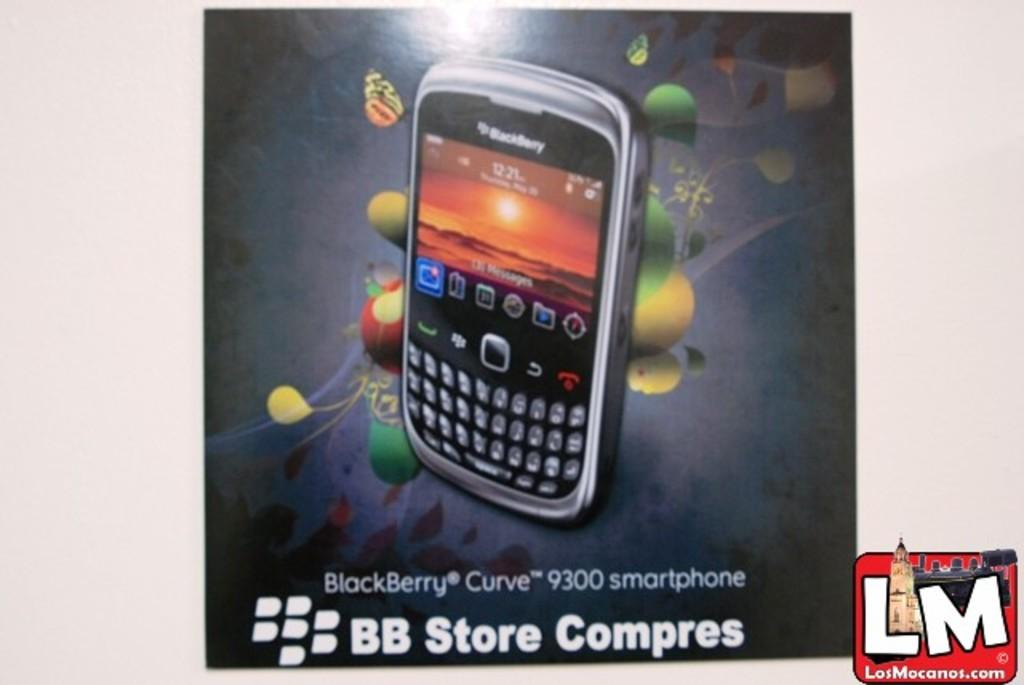<image>
Summarize the visual content of the image. An advertisement for a BlackBerry Curve 9300 smartphone. 